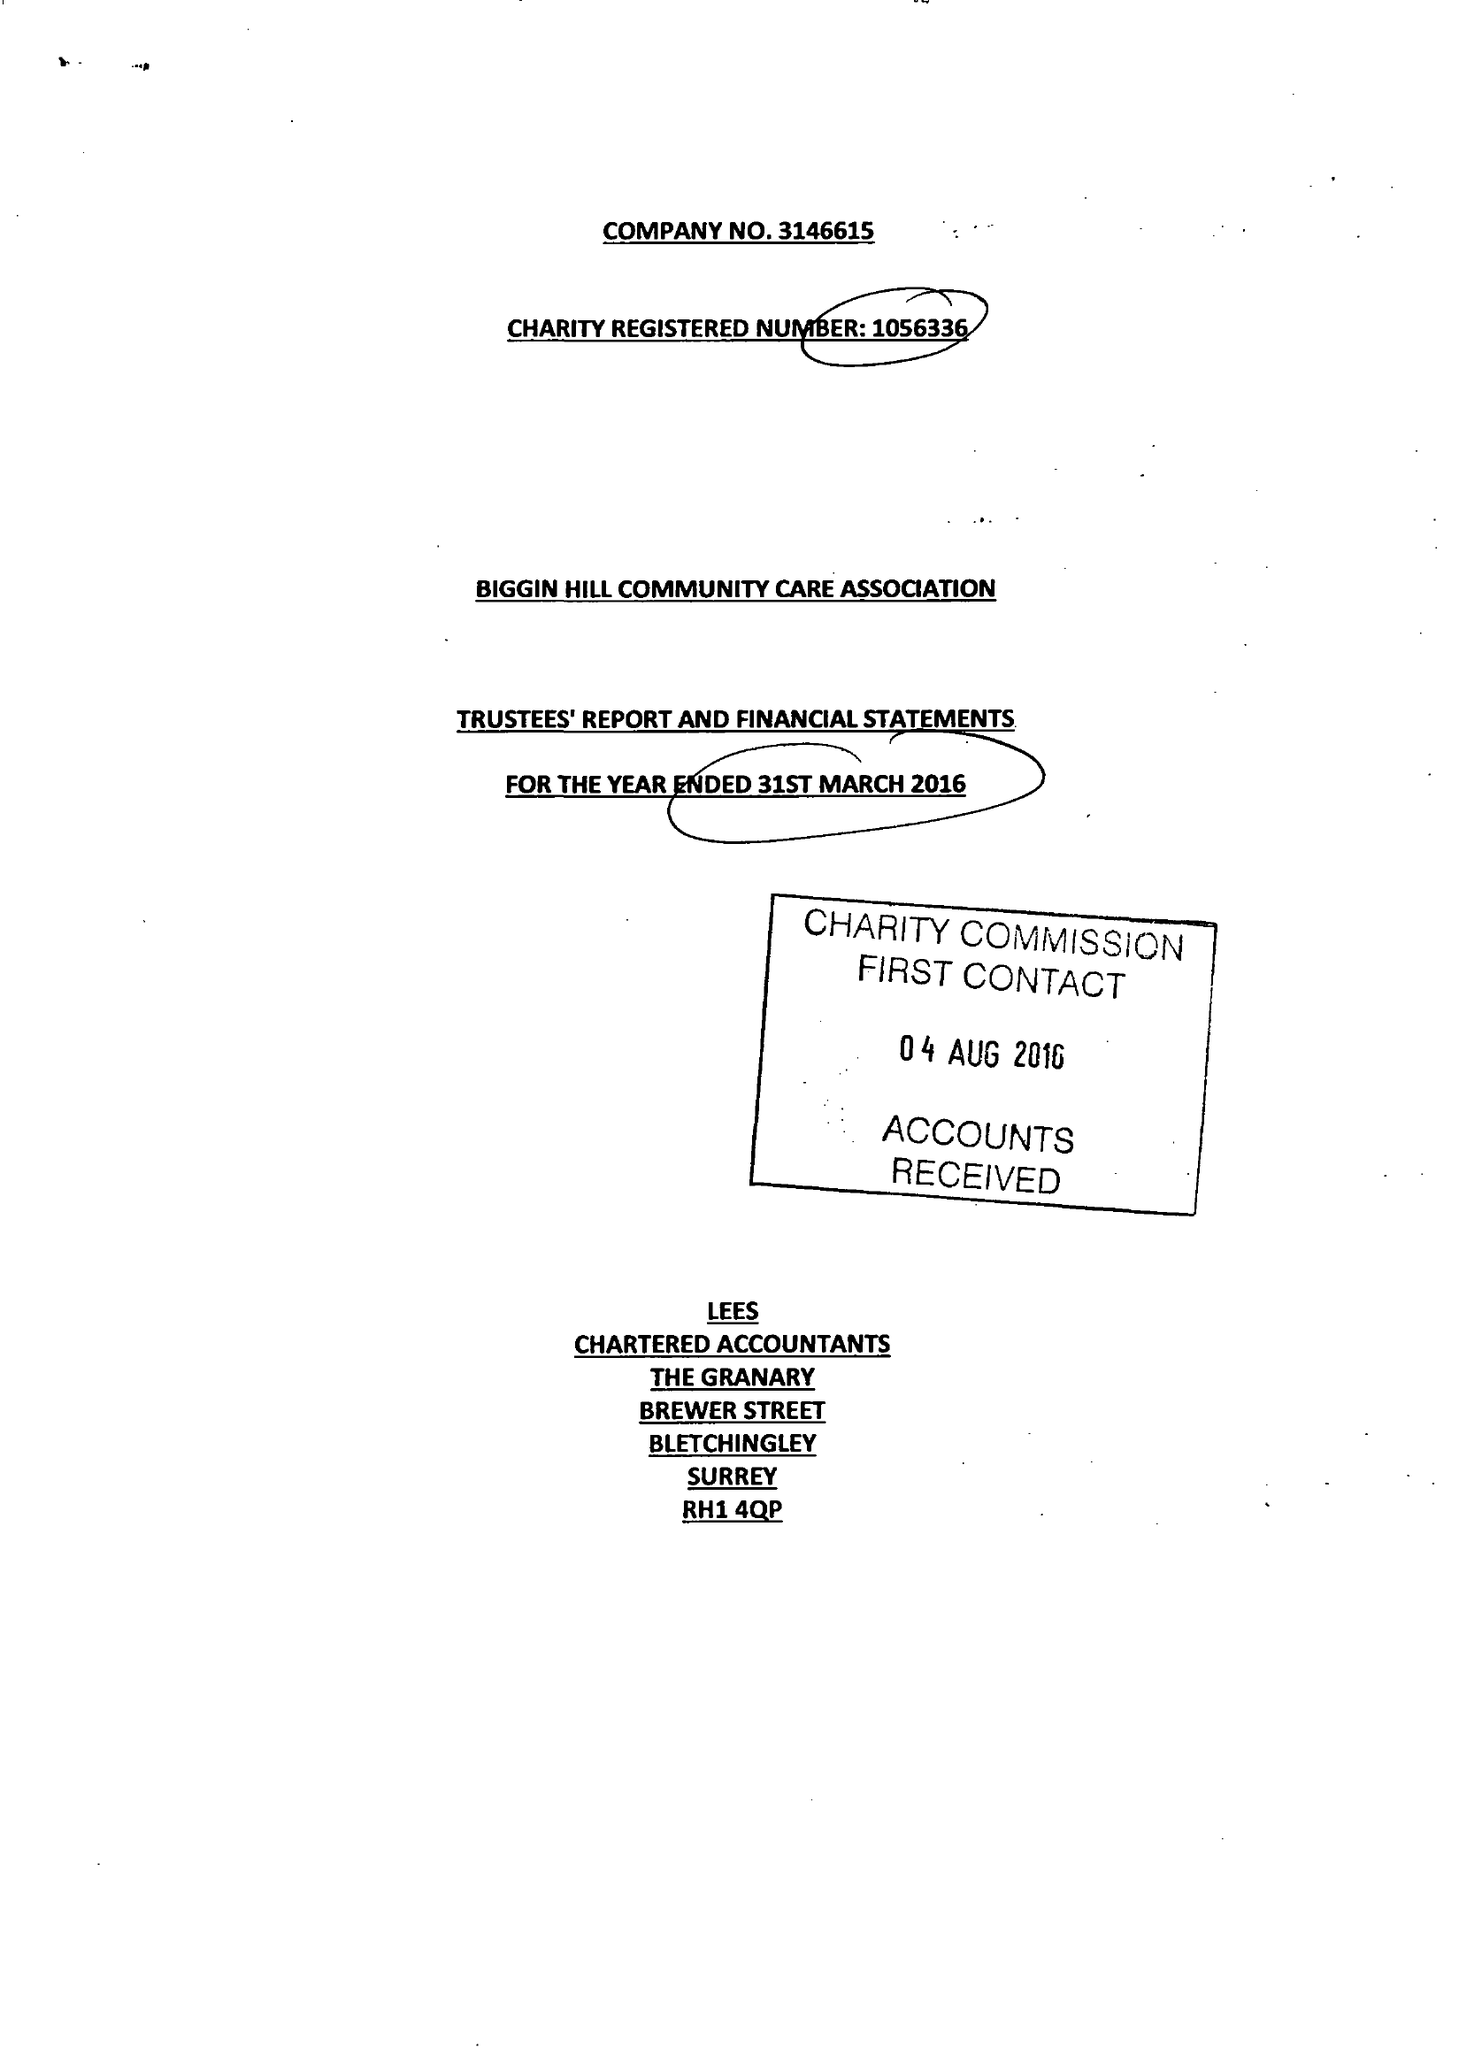What is the value for the charity_number?
Answer the question using a single word or phrase. 1056336 